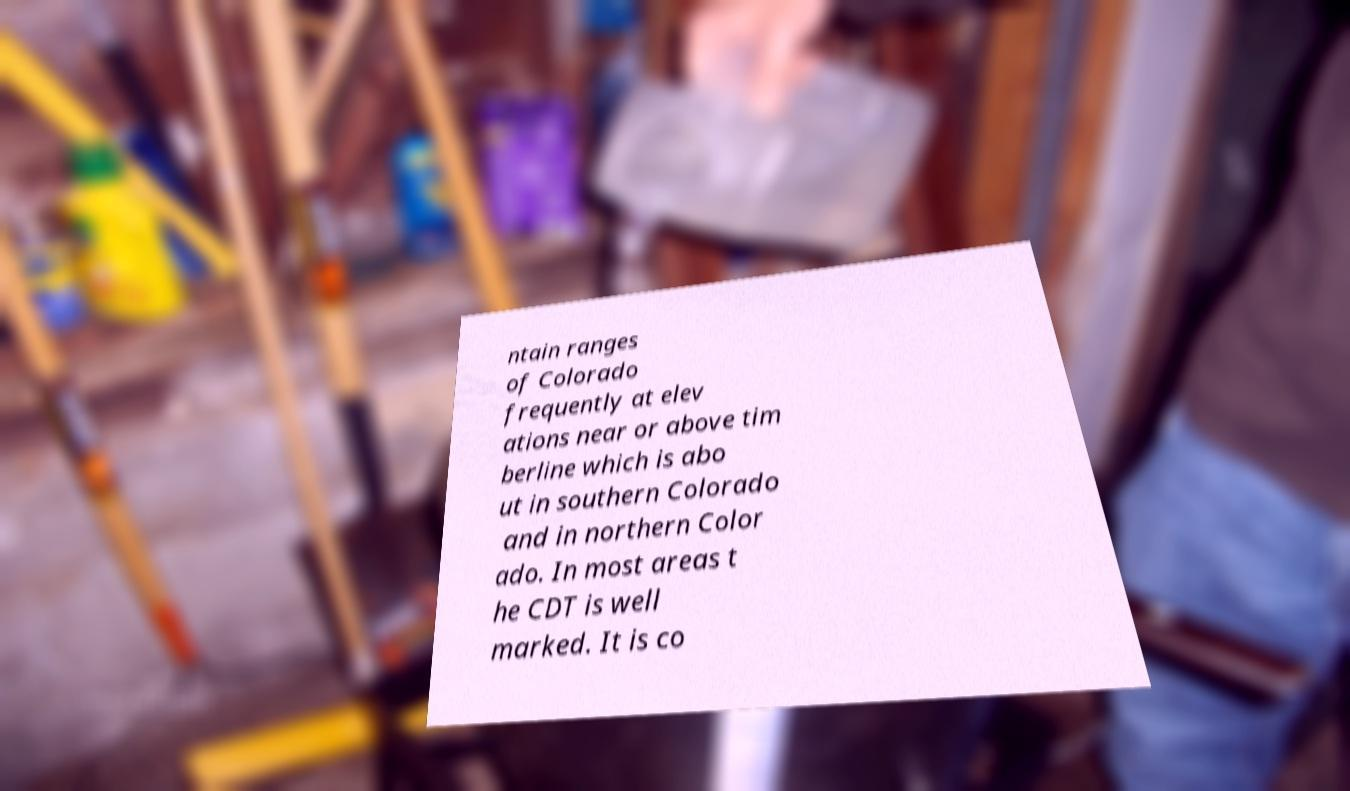What messages or text are displayed in this image? I need them in a readable, typed format. ntain ranges of Colorado frequently at elev ations near or above tim berline which is abo ut in southern Colorado and in northern Color ado. In most areas t he CDT is well marked. It is co 